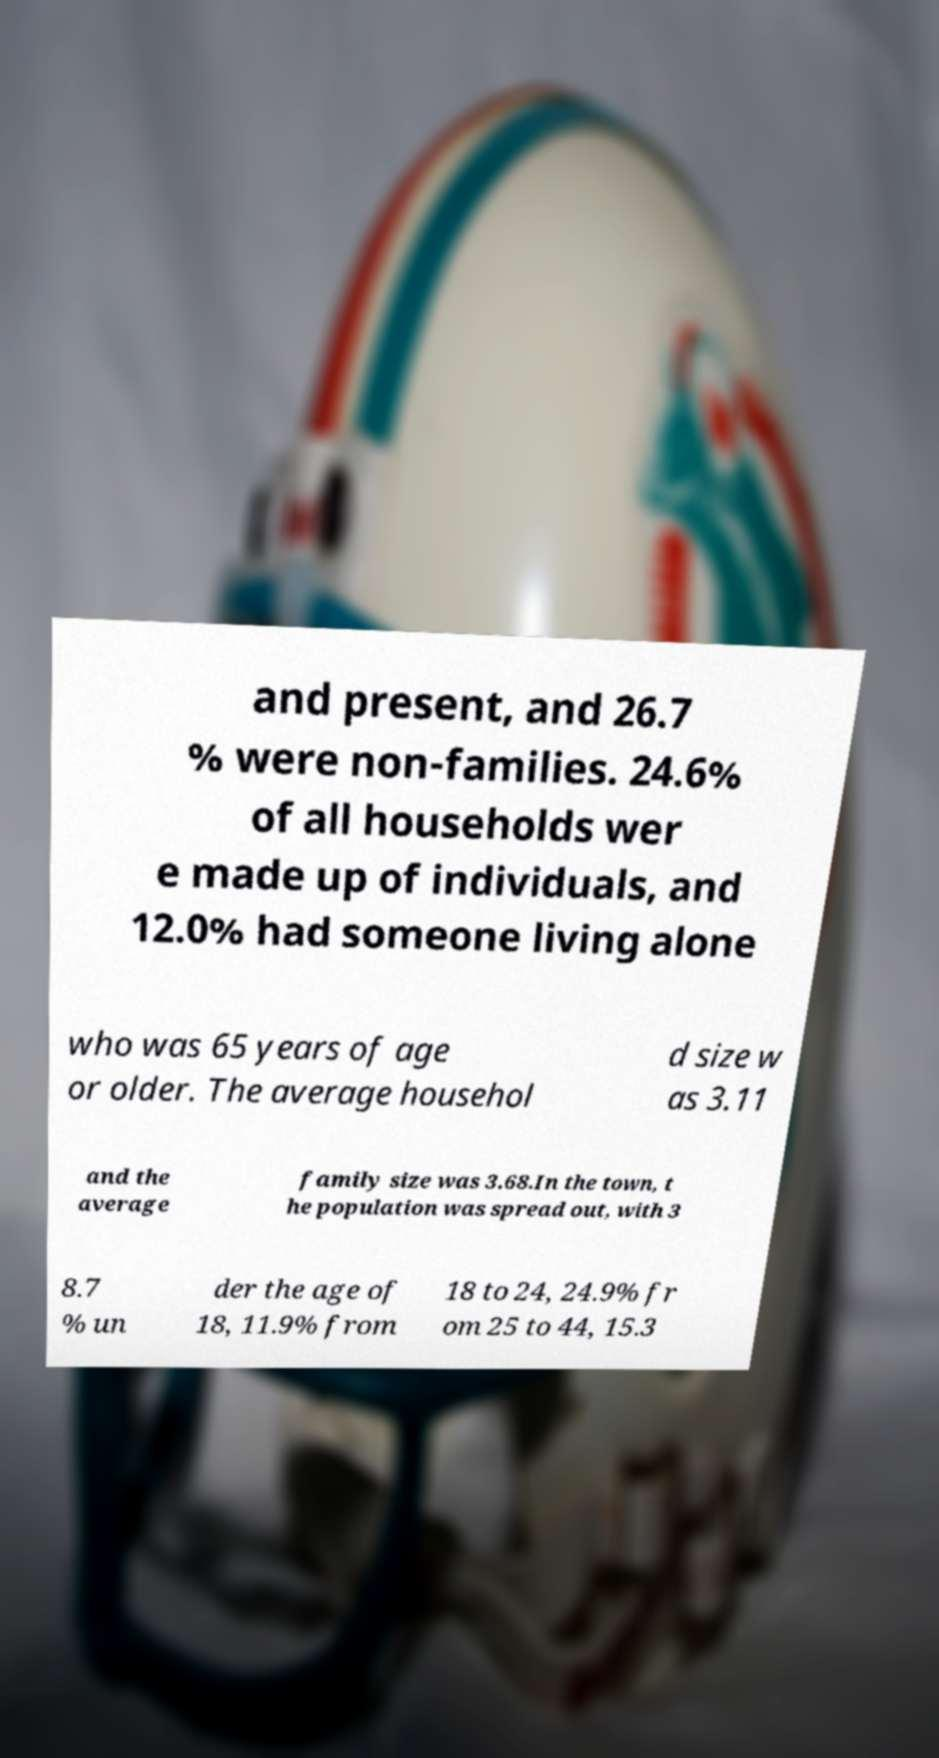I need the written content from this picture converted into text. Can you do that? and present, and 26.7 % were non-families. 24.6% of all households wer e made up of individuals, and 12.0% had someone living alone who was 65 years of age or older. The average househol d size w as 3.11 and the average family size was 3.68.In the town, t he population was spread out, with 3 8.7 % un der the age of 18, 11.9% from 18 to 24, 24.9% fr om 25 to 44, 15.3 